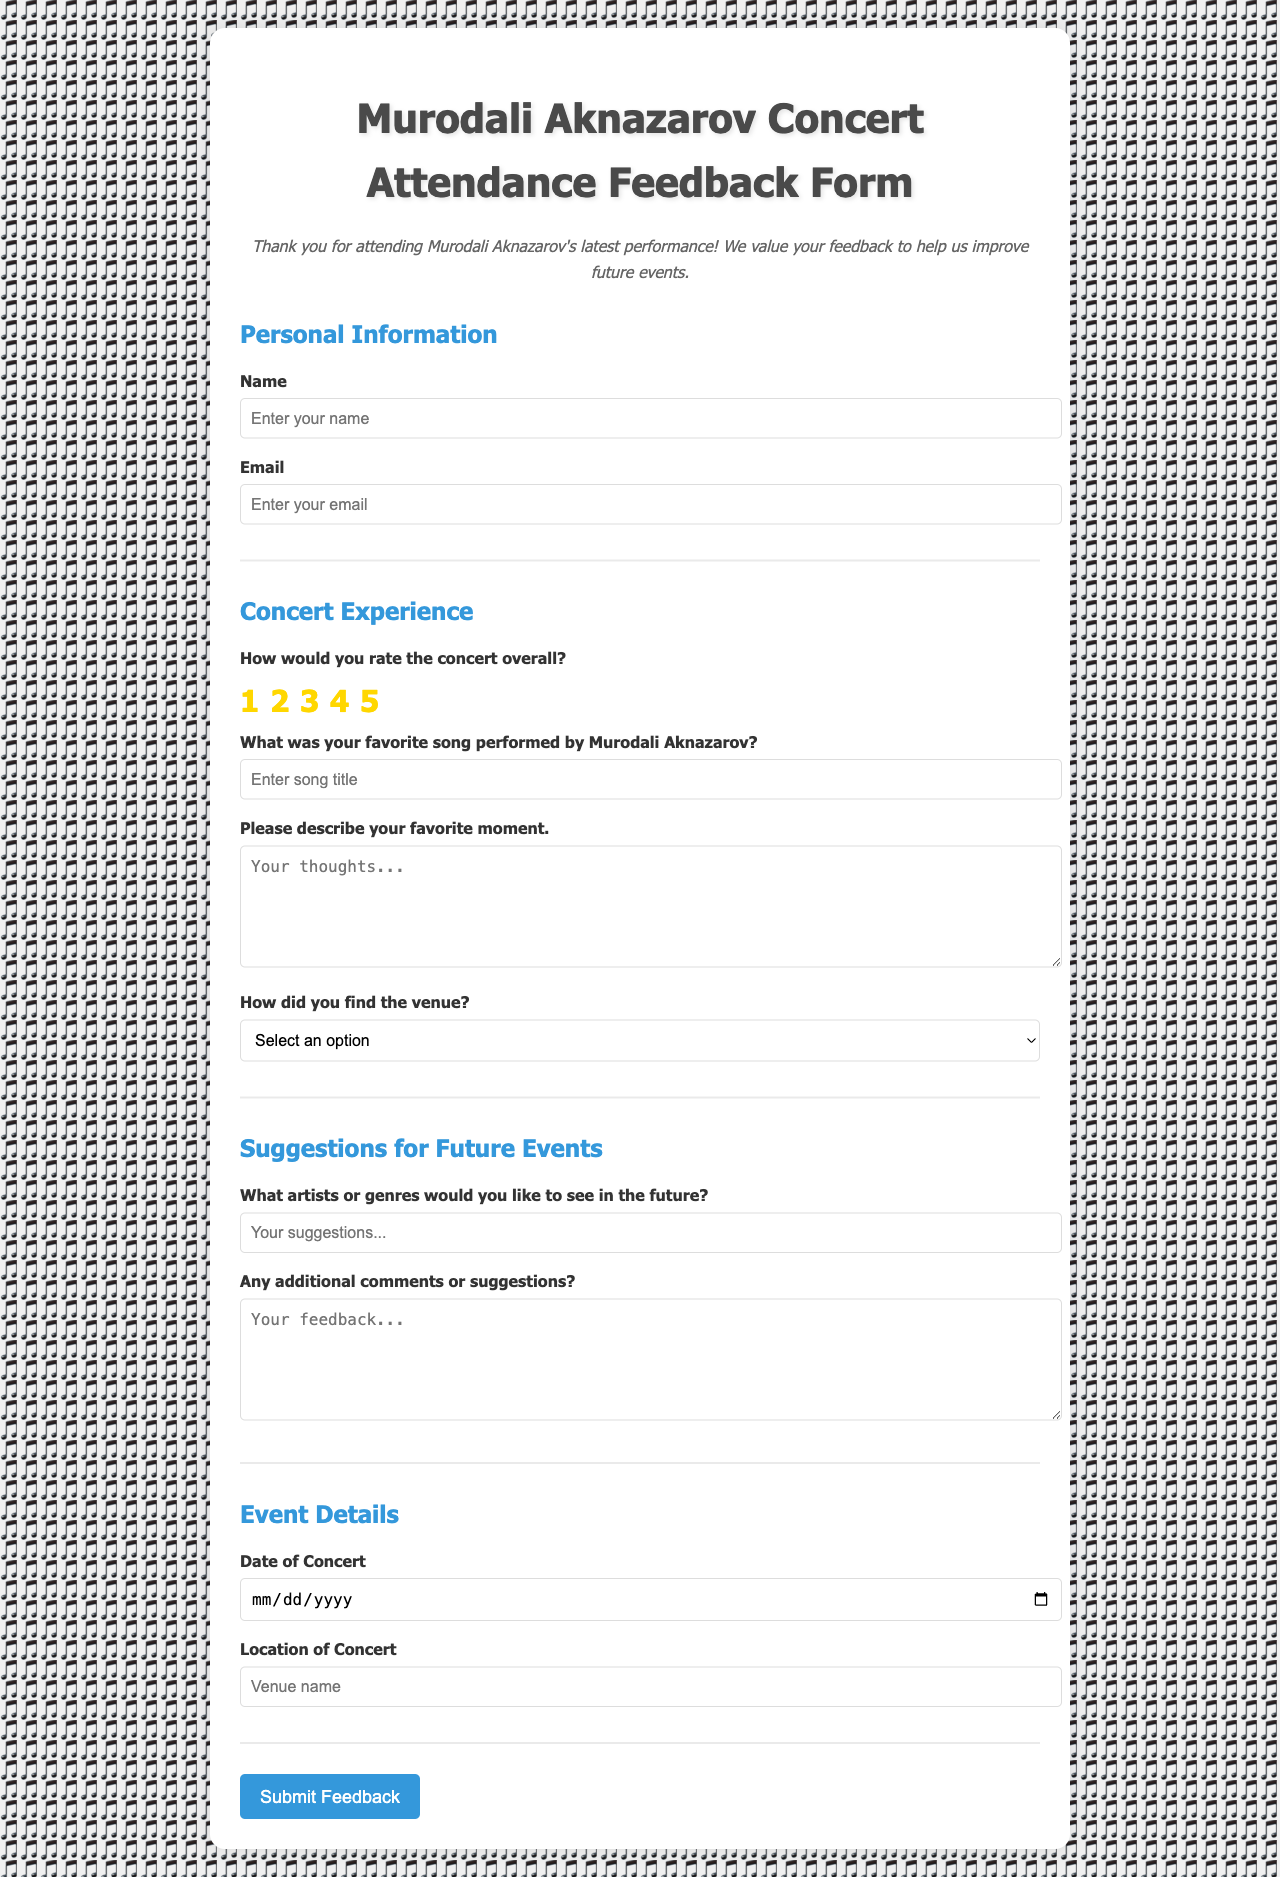What is the title of the document? The title is typically found in the `<title>` tag of the document's head section.
Answer: Murodali Aknazarov Concert Attendance Feedback Form What type of feedback is being collected? The feedback is related to a concert, as indicated in the document's introduction and title.
Answer: Concert experience What date range does the document cover for concert timing? The event details section provides a field for entering the concert date; however, it does not specify a fixed date.
Answer: Not specified What can attendees rate in the feedback form? The feedback form includes a section where attendees can rate their overall concert experience.
Answer: Overall concert experience What is the purpose of the "favorite moment" question? This question asks for attendees to reflect on the most memorable part of the performance based on their personal experience.
Answer: To gather memorable experiences Which two forms of feedback does the document specifically ask for in suggestions? The document prompts attendees to suggest artists or genres, as well as any overall additional comments.
Answer: Artists/genres and additional comments What format is requested for the respondent’s name? The input field for the name requests a text entry to capture the attendee’s name.
Answer: Text What action occurs when the feedback form is submitted? The script section of the document details the behavior when the form is submitted, which includes hiding the form and showing a thank-you message.
Answer: Form is hidden and thank-you message displayed 